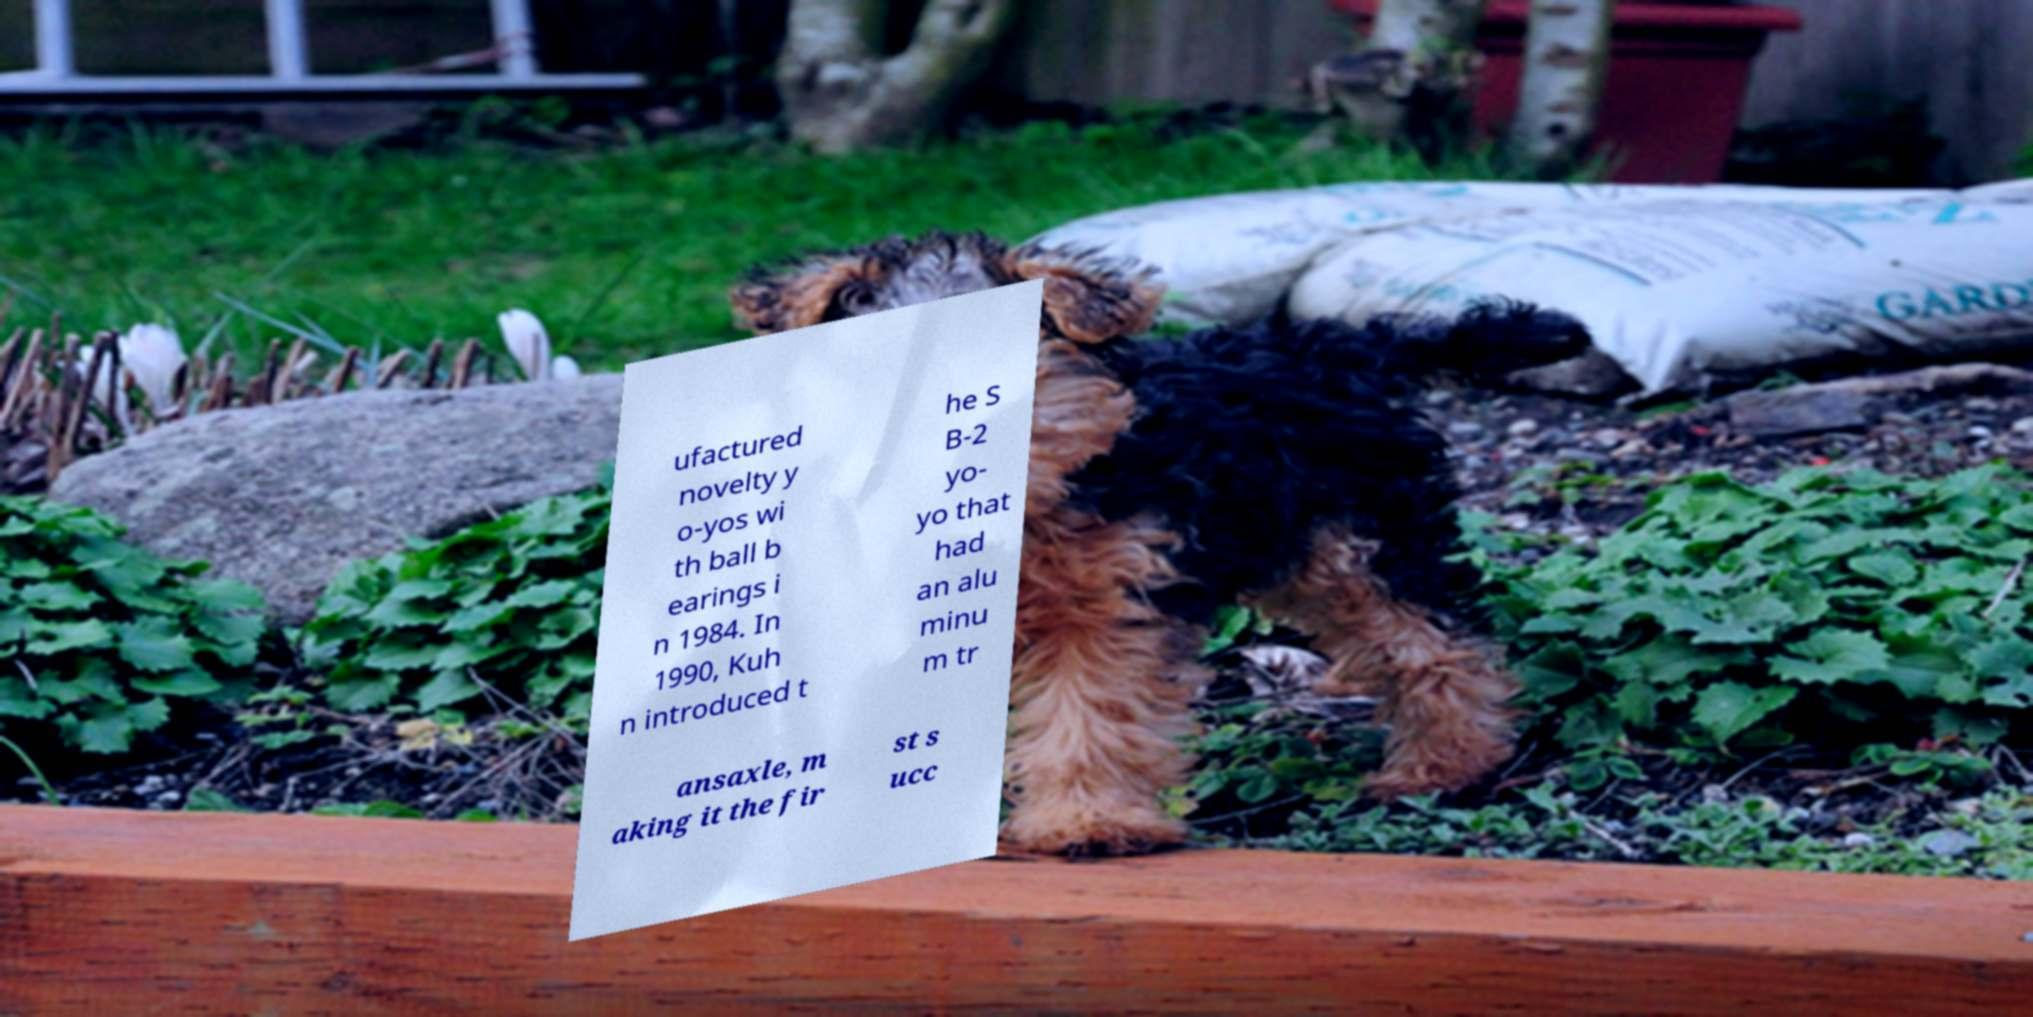There's text embedded in this image that I need extracted. Can you transcribe it verbatim? ufactured novelty y o-yos wi th ball b earings i n 1984. In 1990, Kuh n introduced t he S B-2 yo- yo that had an alu minu m tr ansaxle, m aking it the fir st s ucc 